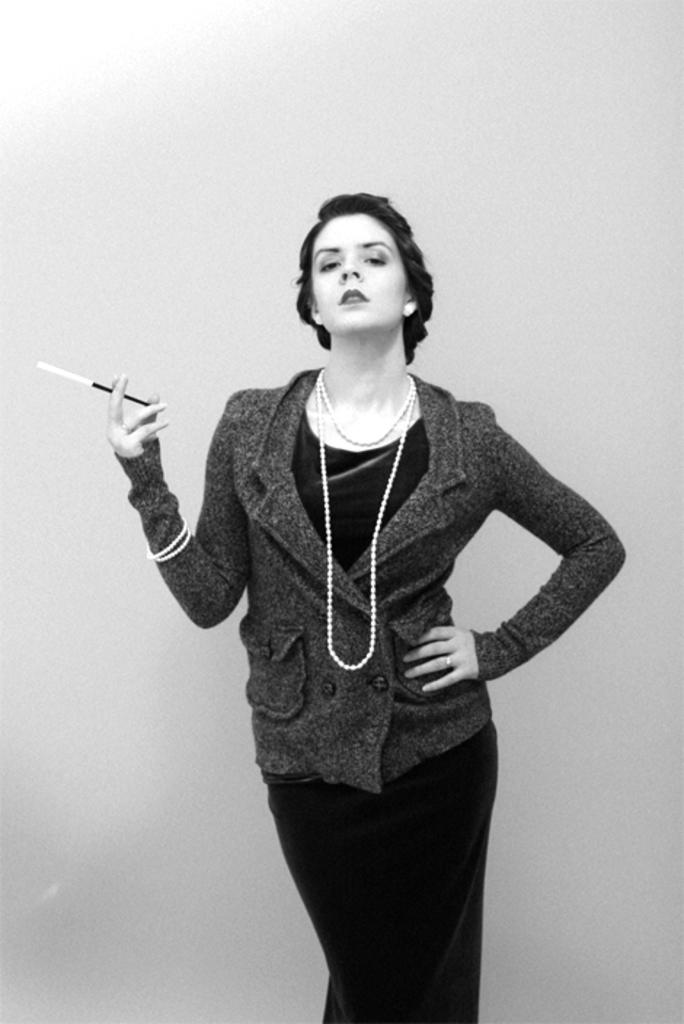What is the color scheme of the image? The image is black and white. Who is present in the image? There is a woman in the image. What is the woman doing in the image? The woman is standing in the image. What object is the woman holding in the image? The woman is holding a stick in the image. What type of pet can be seen lying on the bed in the image? There is no pet or bed present in the image; it only features a woman standing and holding a stick. 